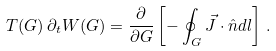Convert formula to latex. <formula><loc_0><loc_0><loc_500><loc_500>T ( G ) \, \partial _ { t } { W } ( G ) = \frac { \partial } { \partial G } \left [ - \oint _ { G } \vec { J } \cdot \hat { n } d l \right ] \, .</formula> 